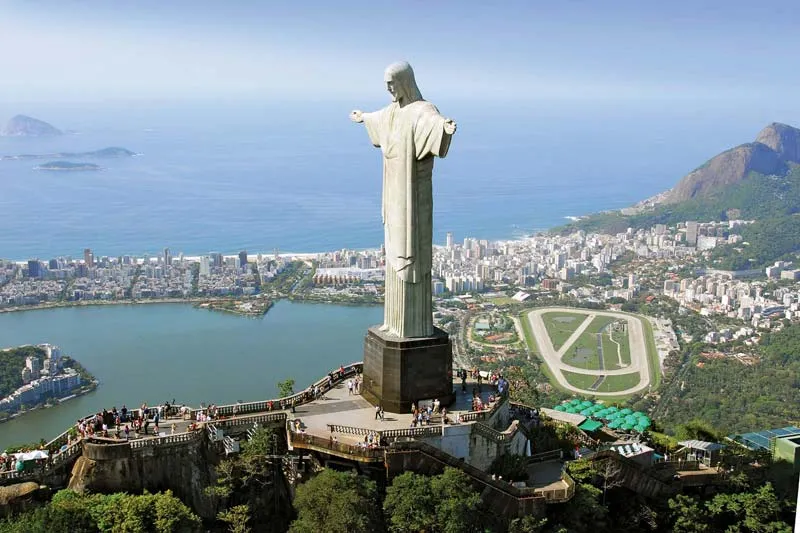Can you describe the main features of this image for me? The image showcases the majestic Cristo Redentor, or Christ the Redeemer, statue towering over Rio de Janeiro, Brazil. The statue, made of reinforced concrete and soapstone, depicts Jesus Christ with outstretched arms, symbolizing peace and inclusiveness. Perched atop the Corcovado Mountain, the statue stands on a robust pedestal, further emphasizing its grandeur.

From the elevated perspective, the vibrant city of Rio de Janeiro spreads out beneath. The blend of modern urban landscape with historical elements nestles amidst lush green hills, creating a dynamic cityscape. This view stretches out to the Atlantic Ocean, adding a tranquil yet majestic touch to the scene.

At the base of the statue, a bustling viewing platform filled with tourists is visible, providing a sense of scale and showcasing the statue’s monumental size. The people appear tiny in comparison, underscoring the colossal nature of the statue.

The image is bathed in warm, natural light, highlighting the statue’s features and the city’s landscape. The clear blue sky offers a flawless backdrop, enhancing the visual impact of the scene.

In essence, the image beautifully captures the awe-inspiring presence of the Cristo Redentor, its harmony with the city it watches over, and the natural beauty of Rio de Janeiro. It portrays a perfect blend of human artistry, spiritual symbolism, and natural splendor. 